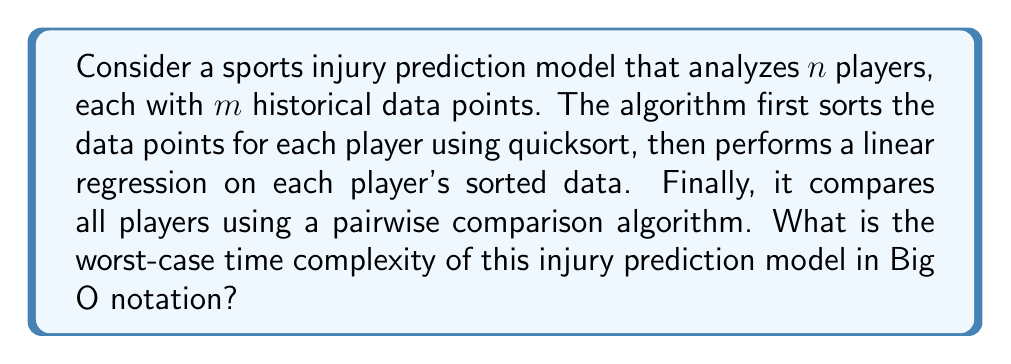What is the answer to this math problem? Let's break down the algorithm and analyze each step:

1. Sorting data points for each player:
   - There are $n$ players, each with $m$ data points.
   - Quicksort has an average-case time complexity of $O(k \log k)$ for $k$ elements.
   - For each player: $O(m \log m)$
   - For all players: $O(n \cdot m \log m)$

2. Linear regression for each player:
   - Linear regression has a time complexity of $O(k)$ for $k$ data points.
   - For each player: $O(m)$
   - For all players: $O(nm)$

3. Pairwise comparison of players:
   - Comparing all pairs of players requires $\frac{n(n-1)}{2}$ comparisons.
   - This results in a time complexity of $O(n^2)$

Now, let's combine these steps:

$$O(n \cdot m \log m) + O(nm) + O(n^2)$$

To determine the worst-case time complexity, we need to consider the dominant term:

- If $m$ is significantly larger than $n$, then $O(n \cdot m \log m)$ dominates.
- If $n$ is significantly larger than $m$, then $O(n^2)$ dominates.

Since we're asked for the worst-case scenario, we should consider the maximum of these two terms:

$$O(\max(n \cdot m \log m, n^2))$$

This expression represents the worst-case time complexity of the injury prediction model.
Answer: $O(\max(n \cdot m \log m, n^2))$ 